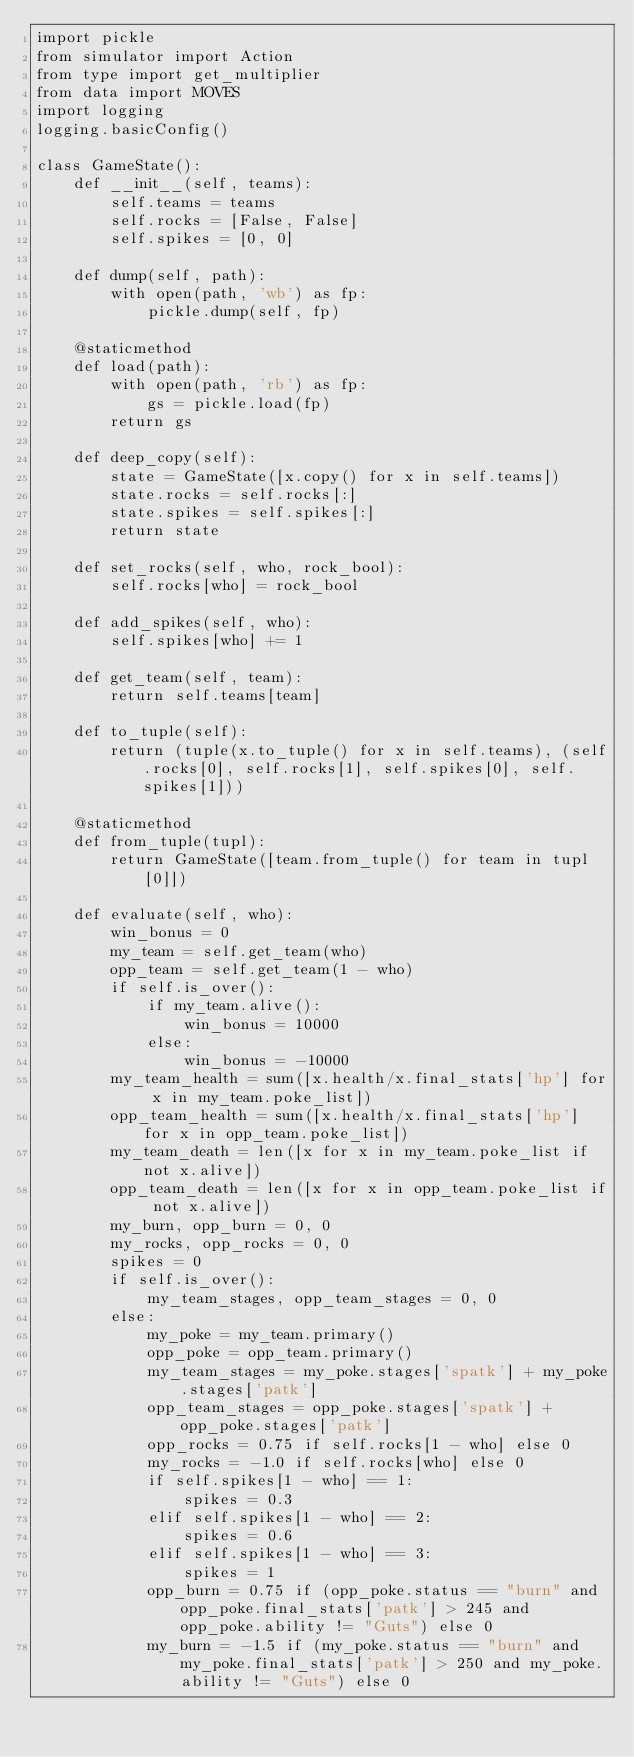<code> <loc_0><loc_0><loc_500><loc_500><_Python_>import pickle
from simulator import Action
from type import get_multiplier
from data import MOVES
import logging
logging.basicConfig()

class GameState():
    def __init__(self, teams):
        self.teams = teams
        self.rocks = [False, False]
        self.spikes = [0, 0]

    def dump(self, path):
        with open(path, 'wb') as fp:
            pickle.dump(self, fp)

    @staticmethod
    def load(path):
        with open(path, 'rb') as fp:
            gs = pickle.load(fp)
        return gs

    def deep_copy(self):
        state = GameState([x.copy() for x in self.teams])
        state.rocks = self.rocks[:]
        state.spikes = self.spikes[:]
        return state

    def set_rocks(self, who, rock_bool):
        self.rocks[who] = rock_bool

    def add_spikes(self, who):
        self.spikes[who] += 1

    def get_team(self, team):
        return self.teams[team]

    def to_tuple(self):
        return (tuple(x.to_tuple() for x in self.teams), (self.rocks[0], self.rocks[1], self.spikes[0], self.spikes[1]))

    @staticmethod
    def from_tuple(tupl):
        return GameState([team.from_tuple() for team in tupl[0]])

    def evaluate(self, who):
        win_bonus = 0
        my_team = self.get_team(who)
        opp_team = self.get_team(1 - who)
        if self.is_over():
            if my_team.alive():
                win_bonus = 10000
            else:
                win_bonus = -10000
        my_team_health = sum([x.health/x.final_stats['hp'] for x in my_team.poke_list])
        opp_team_health = sum([x.health/x.final_stats['hp'] for x in opp_team.poke_list])
        my_team_death = len([x for x in my_team.poke_list if not x.alive])
        opp_team_death = len([x for x in opp_team.poke_list if not x.alive])
        my_burn, opp_burn = 0, 0
        my_rocks, opp_rocks = 0, 0
        spikes = 0
        if self.is_over():
            my_team_stages, opp_team_stages = 0, 0
        else:
            my_poke = my_team.primary()
            opp_poke = opp_team.primary()
            my_team_stages = my_poke.stages['spatk'] + my_poke.stages['patk']
            opp_team_stages = opp_poke.stages['spatk'] + opp_poke.stages['patk']
            opp_rocks = 0.75 if self.rocks[1 - who] else 0
            my_rocks = -1.0 if self.rocks[who] else 0
            if self.spikes[1 - who] == 1:
                spikes = 0.3
            elif self.spikes[1 - who] == 2:
                spikes = 0.6
            elif self.spikes[1 - who] == 3:
                spikes = 1
            opp_burn = 0.75 if (opp_poke.status == "burn" and opp_poke.final_stats['patk'] > 245 and opp_poke.ability != "Guts") else 0
            my_burn = -1.5 if (my_poke.status == "burn" and my_poke.final_stats['patk'] > 250 and my_poke.ability != "Guts") else 0</code> 